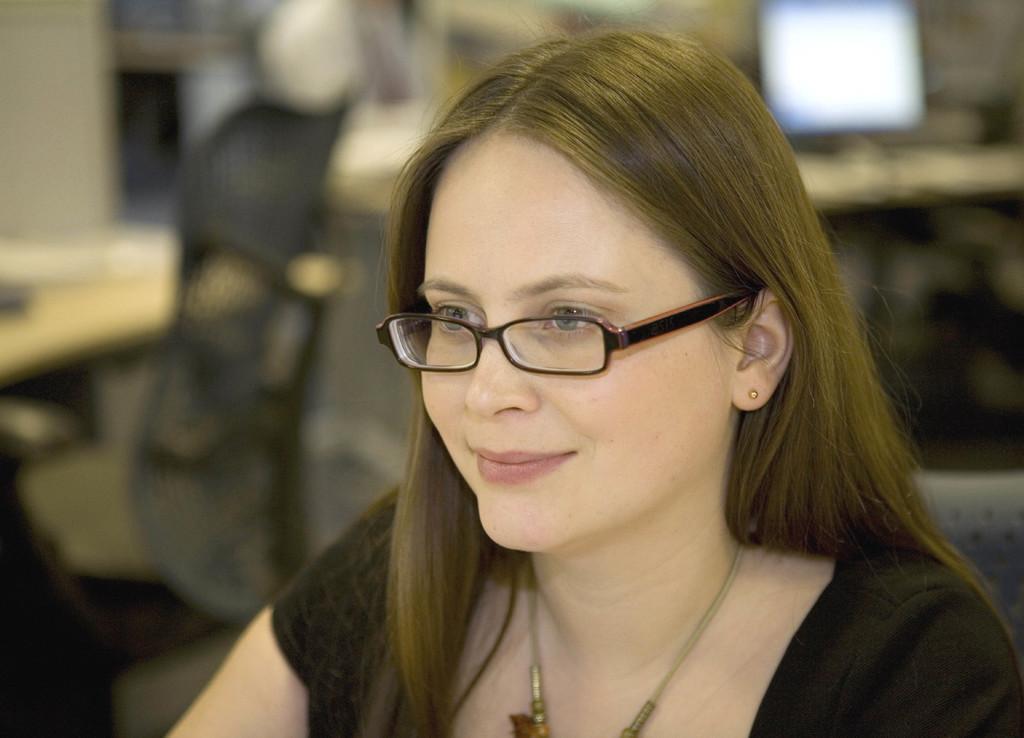Describe this image in one or two sentences. In the foreground of the image there is a lady. The background of the image is blurred. We can see a monitor screen and a chair. 